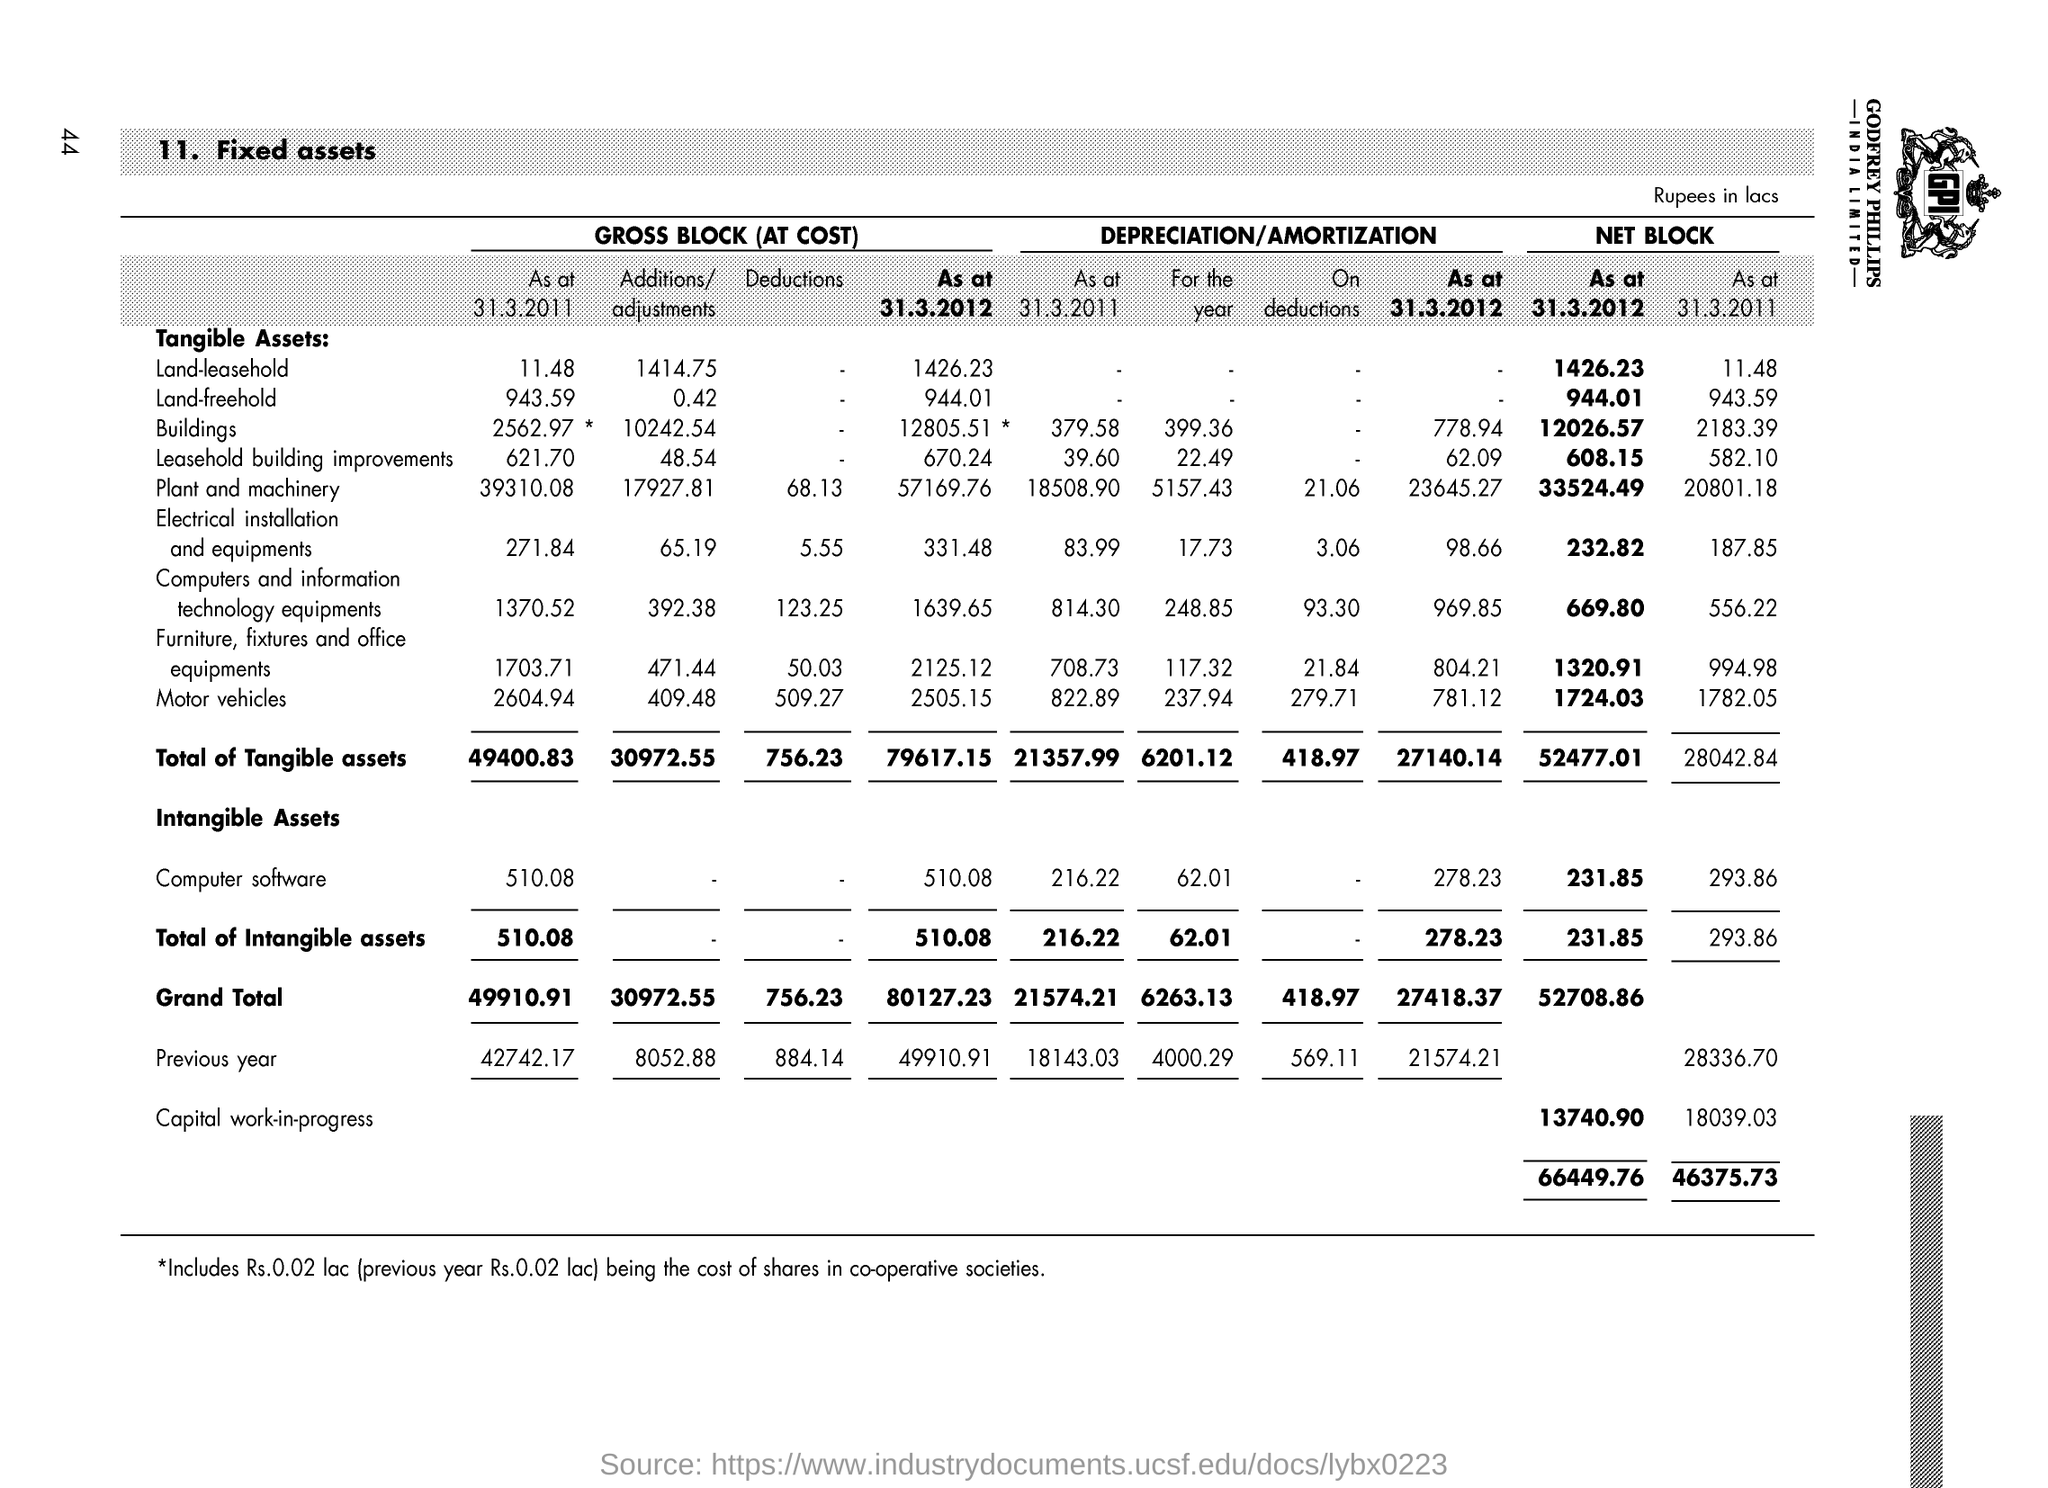What is the Total of Tangible assets for Gross Block(At Cost) As of 31.3.2011?
Keep it short and to the point. 49400.83. What is the Total of Tangible assets  for Gross Block(At Cost) As of 31.3.2012?
Ensure brevity in your answer.  79617.15. What is the Total of Intangible assets for Gross Block(At Cost) As of 31.3.2011?
Your answer should be compact. 510.08. What is the Total of Intangible assets for Gross Block(At Cost) As of 31.3.2012?
Provide a short and direct response. 510.08. What is the Total of Intangible assets for Net Block As of 31.3.2011?
Offer a terse response. 293.86. What is the Total of Intangible assets for Net Block As of 31.3.2012?
Make the answer very short. 231.85. What is the Grand Total for Gross Block(At Cost) As of 31.3.2011?
Your answer should be very brief. 49910.91. What is the Grand Total for Gross Block(At Cost) As of 31.3.2012?
Give a very brief answer. 80127.23. What is the Grand Total for Net Block As of 31.3.2012?
Make the answer very short. 52708.86. What is the Computer software for Gross Block(At Cost) As of 31.3.2012?
Offer a terse response. 510.08. 